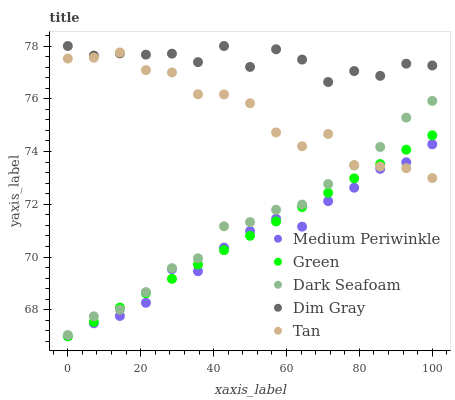Does Medium Periwinkle have the minimum area under the curve?
Answer yes or no. Yes. Does Dim Gray have the maximum area under the curve?
Answer yes or no. Yes. Does Dark Seafoam have the minimum area under the curve?
Answer yes or no. No. Does Dark Seafoam have the maximum area under the curve?
Answer yes or no. No. Is Green the smoothest?
Answer yes or no. Yes. Is Dim Gray the roughest?
Answer yes or no. Yes. Is Dark Seafoam the smoothest?
Answer yes or no. No. Is Dark Seafoam the roughest?
Answer yes or no. No. Does Green have the lowest value?
Answer yes or no. Yes. Does Dark Seafoam have the lowest value?
Answer yes or no. No. Does Dim Gray have the highest value?
Answer yes or no. Yes. Does Dark Seafoam have the highest value?
Answer yes or no. No. Is Medium Periwinkle less than Dim Gray?
Answer yes or no. Yes. Is Dim Gray greater than Medium Periwinkle?
Answer yes or no. Yes. Does Green intersect Dark Seafoam?
Answer yes or no. Yes. Is Green less than Dark Seafoam?
Answer yes or no. No. Is Green greater than Dark Seafoam?
Answer yes or no. No. Does Medium Periwinkle intersect Dim Gray?
Answer yes or no. No. 